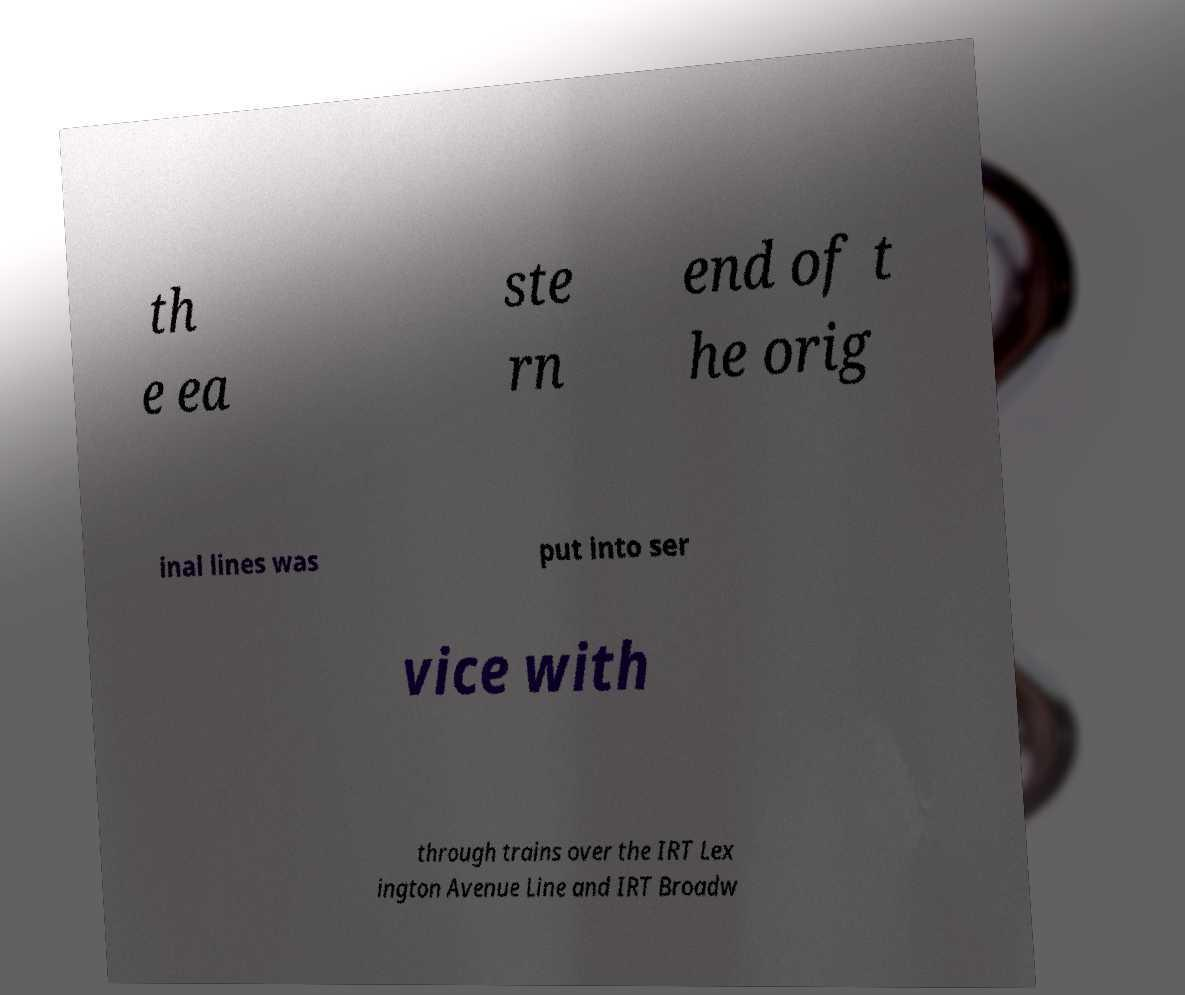There's text embedded in this image that I need extracted. Can you transcribe it verbatim? th e ea ste rn end of t he orig inal lines was put into ser vice with through trains over the IRT Lex ington Avenue Line and IRT Broadw 